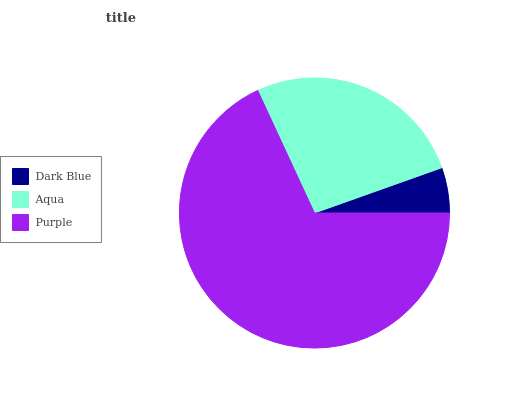Is Dark Blue the minimum?
Answer yes or no. Yes. Is Purple the maximum?
Answer yes or no. Yes. Is Aqua the minimum?
Answer yes or no. No. Is Aqua the maximum?
Answer yes or no. No. Is Aqua greater than Dark Blue?
Answer yes or no. Yes. Is Dark Blue less than Aqua?
Answer yes or no. Yes. Is Dark Blue greater than Aqua?
Answer yes or no. No. Is Aqua less than Dark Blue?
Answer yes or no. No. Is Aqua the high median?
Answer yes or no. Yes. Is Aqua the low median?
Answer yes or no. Yes. Is Dark Blue the high median?
Answer yes or no. No. Is Purple the low median?
Answer yes or no. No. 